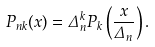<formula> <loc_0><loc_0><loc_500><loc_500>P _ { n k } ( x ) = \Delta _ { n } ^ { k } P _ { k } \left ( \frac { x } { \Delta _ { n } } \right ) .</formula> 